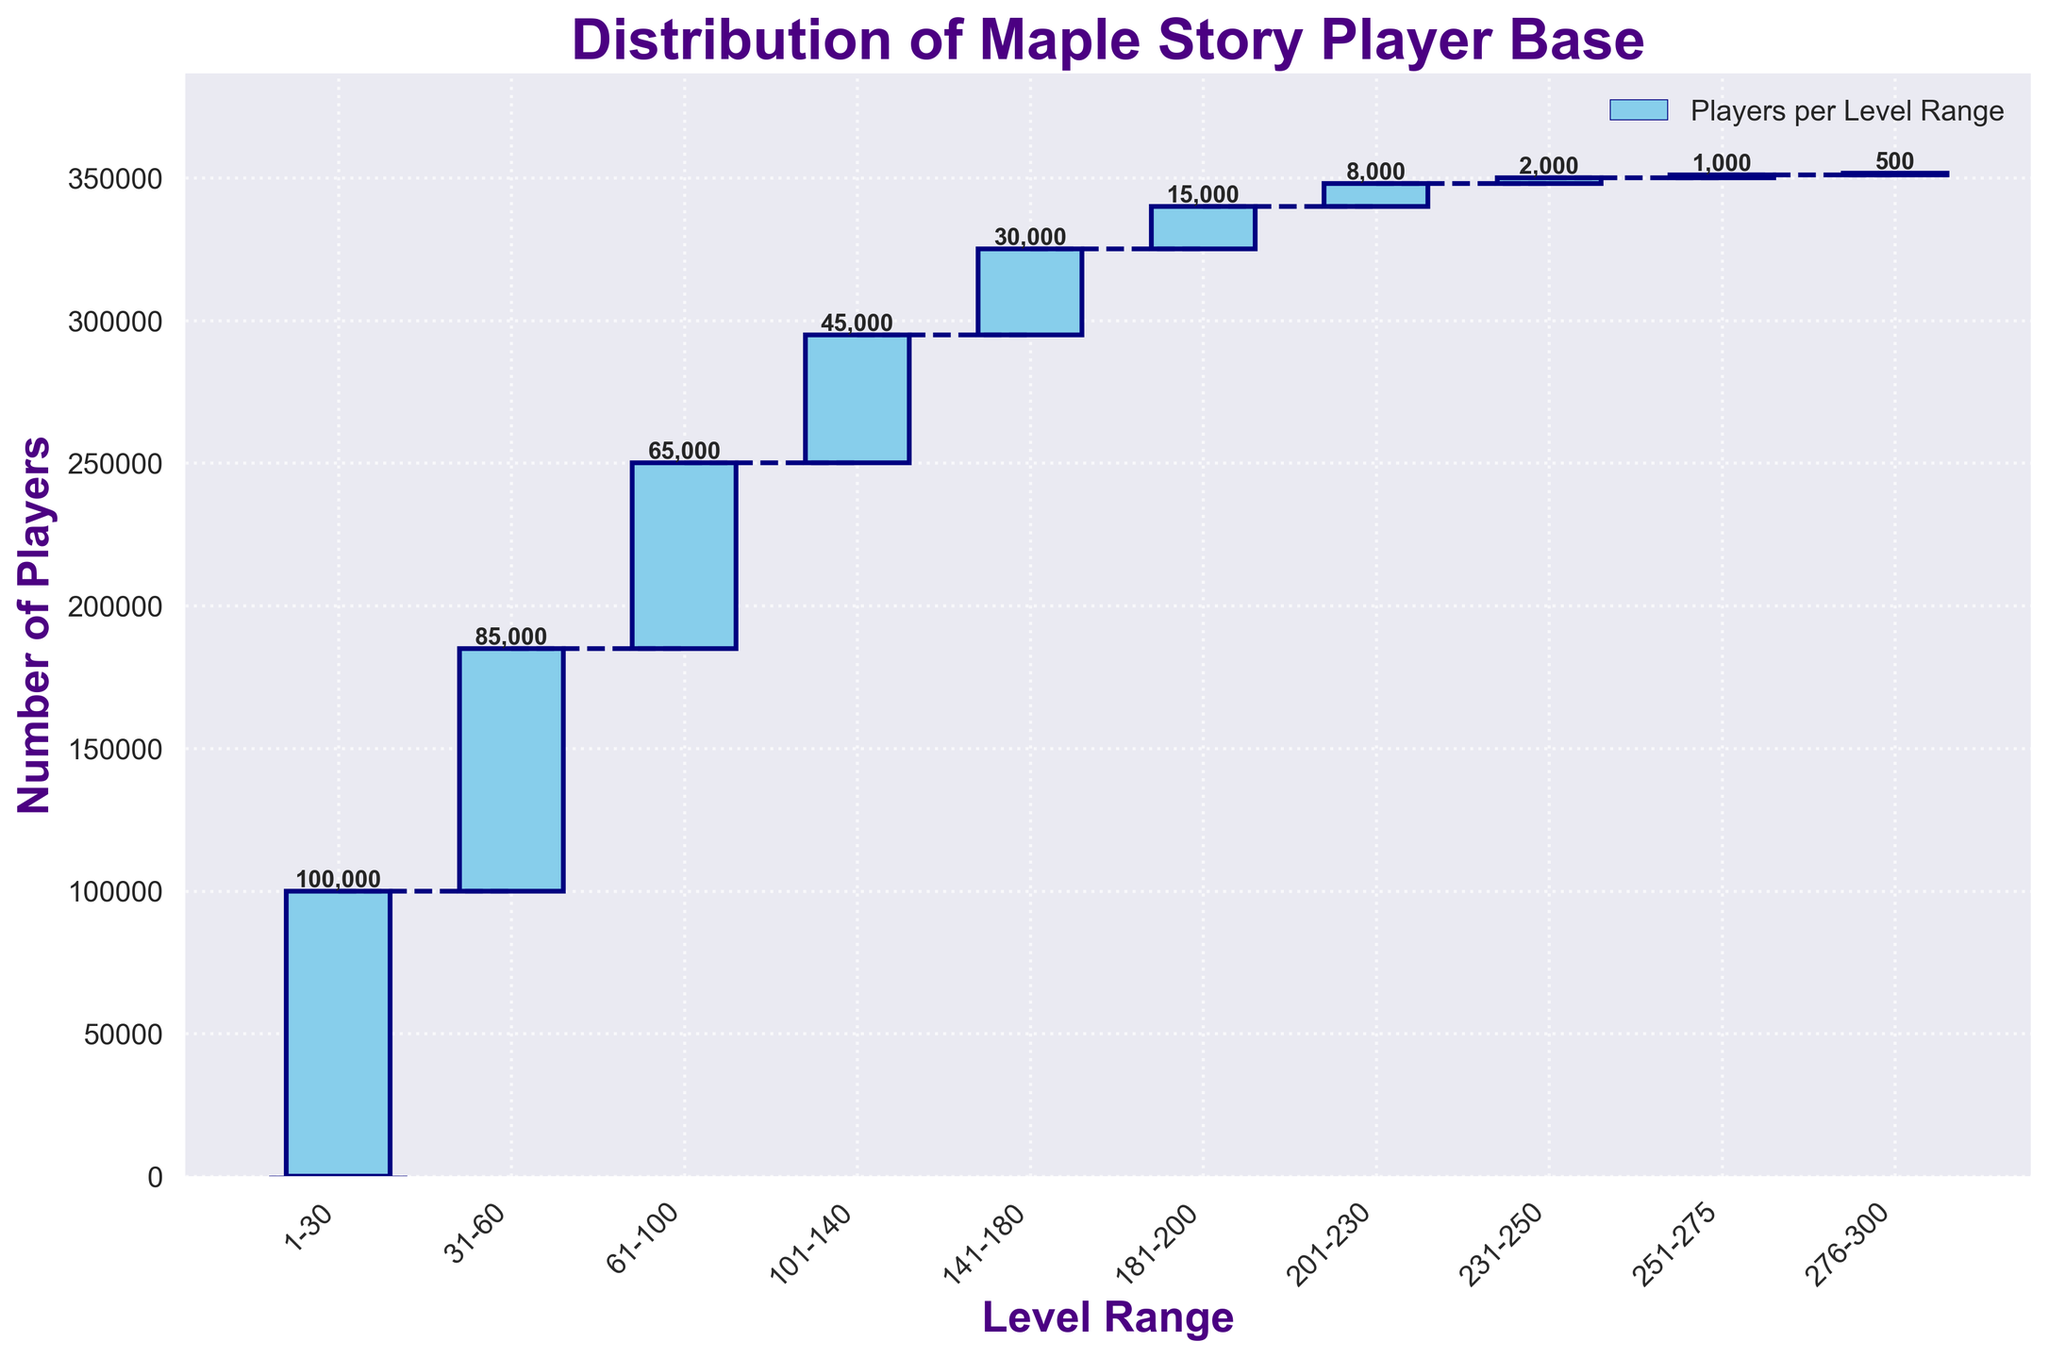What's the title of the chart? The title is the text displayed at the top of the chart. In this chart, the title is displayed prominently in a larger font.
Answer: Distribution of Maple Story Player Base How many players are there in the level range 101-140? Look at the bar corresponding to the level range 101-140. The number is labeled at the top of the bar.
Answer: 45,000 Between which two level ranges is there the steepest drop in the number of players? Analyze the slope of the connecting lines between adjacent bars. The steepest drop will have the largest difference in player counts.
Answer: 181-200 and 201-230 What is the cumulative number of players up to the level range 60-100? The cumulative value for a level range is the sum of all previous players up to and including that range. Add the number of players from ranges 1-30, 31-60, and 61-100. 100,000 + 85,000 + 65,000
Answer: 250,000 What is the overall trend in the number of players as the level range increases? Observe the heights of the bars from left to right. Generally describe the direction they move as level range increases.
Answer: Decreasing How does the number of players in 231-250 compare to 251-275? Compare the heights of the bars for 231-250 and 251-275 or the values labeled at the top of each bar.
Answer: 231-250 has more players Which level range has the fewest players? Identify the shortest bar or the smallest number labeled at the top of each bar.
Answer: 276-300 What's the total number of players according to the chart? Add the number of players for each level range: 100,000 + 85,000 + 65,000 + 45,000 + 30,000 + 15,000 + 8,000 + 2,000 + 1,000 + 500
Answer: 351,500 